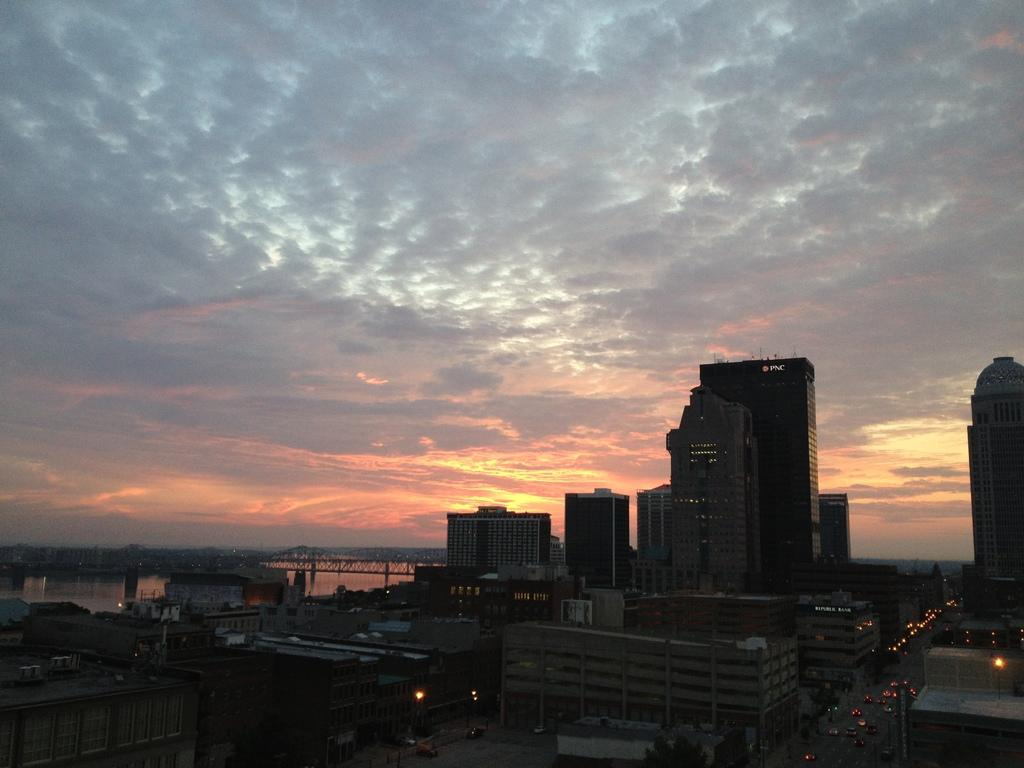What type of structures can be seen in the image? There are buildings in the image. What can be found alongside the buildings? There are roads in the image. What is moving along the roads? There are cars on the road. What natural feature can be seen in the background of the image? There is a river in the background of the image. How is the river crossed in the image? There is a bridge across the river in the background. What part of the environment is visible above the buildings and roads? The sky is visible in the image. What type of hair can be seen on the cars in the image? There is no hair present on the cars in the image; they are vehicles, not living beings. What type of action is the eggnog performing in the image? There is no eggnog present in the image, so it cannot perform any actions. 